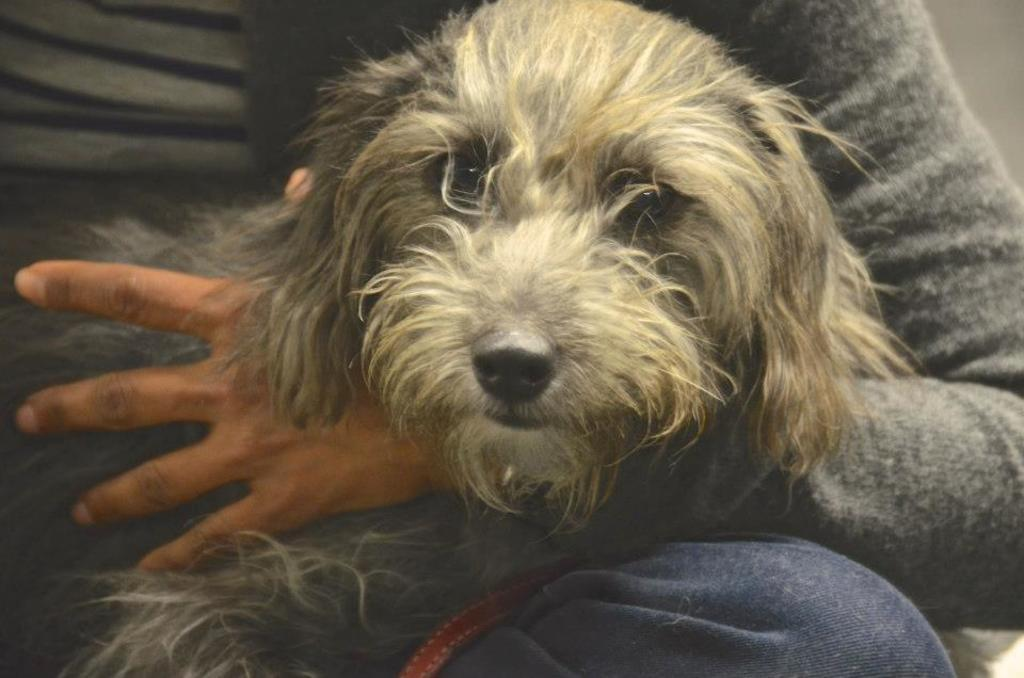What is the person in the image doing? There is a person sitting in the image. What is the person holding in the image? The person is holding a dog. What type of lettuce can be seen growing in the image? There is no lettuce present in the image. What type of shoe is the person wearing in the image? The image does not show the person's shoes, so it cannot be determined what type of shoe they might be wearing. 